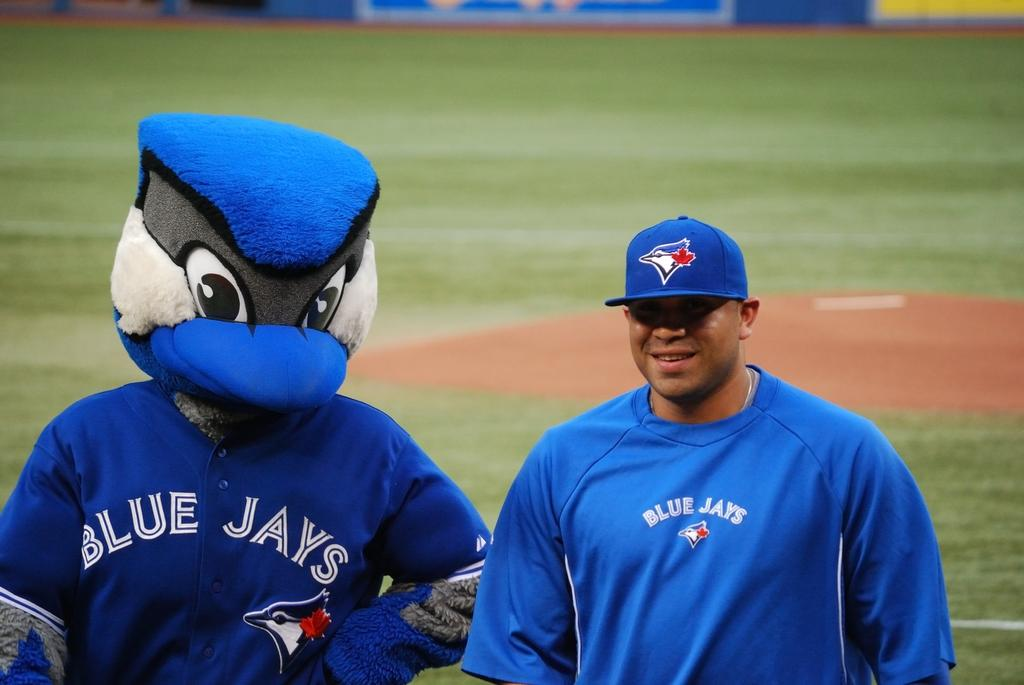<image>
Share a concise interpretation of the image provided. A man standing next to the blue jays mascot 